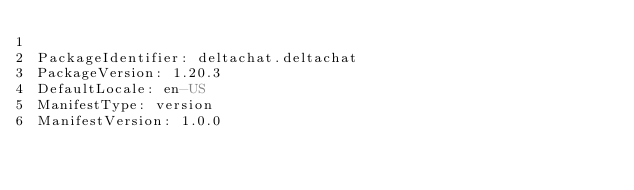Convert code to text. <code><loc_0><loc_0><loc_500><loc_500><_YAML_>
PackageIdentifier: deltachat.deltachat
PackageVersion: 1.20.3
DefaultLocale: en-US
ManifestType: version
ManifestVersion: 1.0.0

</code> 